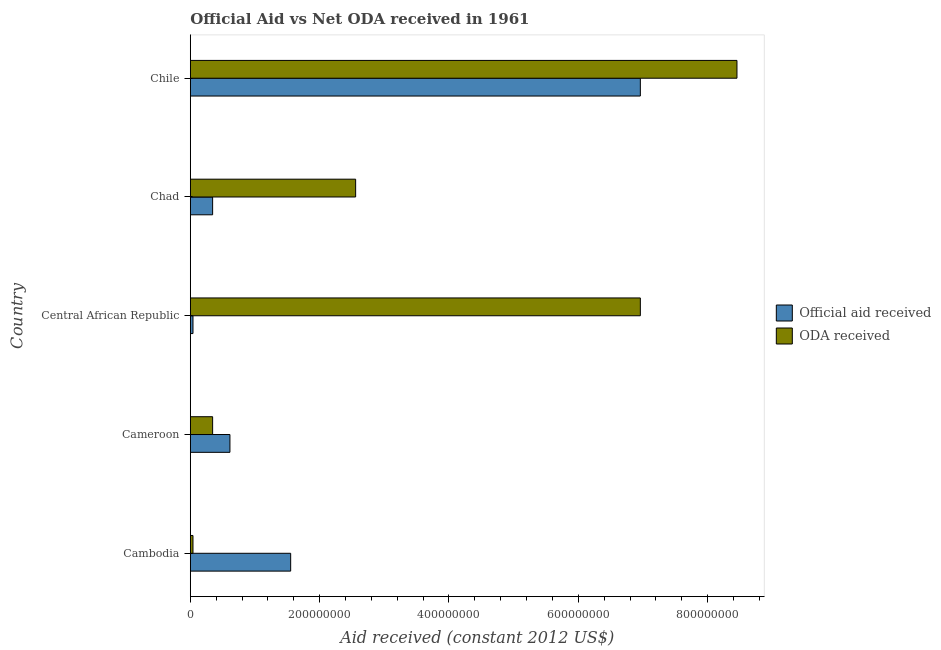How many different coloured bars are there?
Make the answer very short. 2. How many groups of bars are there?
Make the answer very short. 5. Are the number of bars per tick equal to the number of legend labels?
Your answer should be compact. Yes. Are the number of bars on each tick of the Y-axis equal?
Make the answer very short. Yes. What is the label of the 1st group of bars from the top?
Your answer should be very brief. Chile. What is the oda received in Cameroon?
Give a very brief answer. 3.45e+07. Across all countries, what is the maximum oda received?
Offer a very short reply. 8.45e+08. Across all countries, what is the minimum oda received?
Your answer should be very brief. 4.17e+06. In which country was the oda received maximum?
Your response must be concise. Chile. In which country was the oda received minimum?
Your response must be concise. Cambodia. What is the total oda received in the graph?
Provide a short and direct response. 1.84e+09. What is the difference between the official aid received in Cambodia and that in Chile?
Your answer should be very brief. -5.41e+08. What is the difference between the oda received in Central African Republic and the official aid received in Chile?
Keep it short and to the point. 0. What is the average official aid received per country?
Provide a short and direct response. 1.90e+08. What is the difference between the official aid received and oda received in Chad?
Keep it short and to the point. -2.21e+08. In how many countries, is the official aid received greater than 80000000 US$?
Ensure brevity in your answer.  2. What is the ratio of the official aid received in Central African Republic to that in Chile?
Keep it short and to the point. 0.01. What is the difference between the highest and the second highest official aid received?
Ensure brevity in your answer.  5.41e+08. What is the difference between the highest and the lowest oda received?
Offer a terse response. 8.41e+08. In how many countries, is the oda received greater than the average oda received taken over all countries?
Make the answer very short. 2. What does the 2nd bar from the top in Cameroon represents?
Your answer should be compact. Official aid received. What does the 2nd bar from the bottom in Cameroon represents?
Provide a succinct answer. ODA received. How many bars are there?
Offer a terse response. 10. Are all the bars in the graph horizontal?
Offer a terse response. Yes. What is the difference between two consecutive major ticks on the X-axis?
Offer a very short reply. 2.00e+08. Does the graph contain grids?
Keep it short and to the point. No. Where does the legend appear in the graph?
Keep it short and to the point. Center right. How are the legend labels stacked?
Provide a short and direct response. Vertical. What is the title of the graph?
Make the answer very short. Official Aid vs Net ODA received in 1961 . Does "Registered firms" appear as one of the legend labels in the graph?
Provide a short and direct response. No. What is the label or title of the X-axis?
Keep it short and to the point. Aid received (constant 2012 US$). What is the Aid received (constant 2012 US$) of Official aid received in Cambodia?
Keep it short and to the point. 1.55e+08. What is the Aid received (constant 2012 US$) of ODA received in Cambodia?
Offer a very short reply. 4.17e+06. What is the Aid received (constant 2012 US$) in Official aid received in Cameroon?
Your answer should be compact. 6.13e+07. What is the Aid received (constant 2012 US$) in ODA received in Cameroon?
Keep it short and to the point. 3.45e+07. What is the Aid received (constant 2012 US$) of Official aid received in Central African Republic?
Offer a very short reply. 4.17e+06. What is the Aid received (constant 2012 US$) of ODA received in Central African Republic?
Your answer should be very brief. 6.96e+08. What is the Aid received (constant 2012 US$) of Official aid received in Chad?
Your response must be concise. 3.45e+07. What is the Aid received (constant 2012 US$) in ODA received in Chad?
Make the answer very short. 2.56e+08. What is the Aid received (constant 2012 US$) of Official aid received in Chile?
Make the answer very short. 6.96e+08. What is the Aid received (constant 2012 US$) in ODA received in Chile?
Offer a terse response. 8.45e+08. Across all countries, what is the maximum Aid received (constant 2012 US$) in Official aid received?
Your answer should be very brief. 6.96e+08. Across all countries, what is the maximum Aid received (constant 2012 US$) of ODA received?
Give a very brief answer. 8.45e+08. Across all countries, what is the minimum Aid received (constant 2012 US$) of Official aid received?
Provide a succinct answer. 4.17e+06. Across all countries, what is the minimum Aid received (constant 2012 US$) of ODA received?
Your answer should be compact. 4.17e+06. What is the total Aid received (constant 2012 US$) of Official aid received in the graph?
Your answer should be compact. 9.51e+08. What is the total Aid received (constant 2012 US$) of ODA received in the graph?
Offer a very short reply. 1.84e+09. What is the difference between the Aid received (constant 2012 US$) of Official aid received in Cambodia and that in Cameroon?
Offer a very short reply. 9.39e+07. What is the difference between the Aid received (constant 2012 US$) in ODA received in Cambodia and that in Cameroon?
Provide a short and direct response. -3.04e+07. What is the difference between the Aid received (constant 2012 US$) of Official aid received in Cambodia and that in Central African Republic?
Your response must be concise. 1.51e+08. What is the difference between the Aid received (constant 2012 US$) in ODA received in Cambodia and that in Central African Republic?
Provide a succinct answer. -6.92e+08. What is the difference between the Aid received (constant 2012 US$) of Official aid received in Cambodia and that in Chad?
Your answer should be very brief. 1.21e+08. What is the difference between the Aid received (constant 2012 US$) in ODA received in Cambodia and that in Chad?
Offer a terse response. -2.52e+08. What is the difference between the Aid received (constant 2012 US$) of Official aid received in Cambodia and that in Chile?
Make the answer very short. -5.41e+08. What is the difference between the Aid received (constant 2012 US$) of ODA received in Cambodia and that in Chile?
Your response must be concise. -8.41e+08. What is the difference between the Aid received (constant 2012 US$) of Official aid received in Cameroon and that in Central African Republic?
Your response must be concise. 5.71e+07. What is the difference between the Aid received (constant 2012 US$) of ODA received in Cameroon and that in Central African Republic?
Your answer should be compact. -6.61e+08. What is the difference between the Aid received (constant 2012 US$) in Official aid received in Cameroon and that in Chad?
Offer a terse response. 2.68e+07. What is the difference between the Aid received (constant 2012 US$) in ODA received in Cameroon and that in Chad?
Keep it short and to the point. -2.21e+08. What is the difference between the Aid received (constant 2012 US$) of Official aid received in Cameroon and that in Chile?
Provide a succinct answer. -6.35e+08. What is the difference between the Aid received (constant 2012 US$) in ODA received in Cameroon and that in Chile?
Provide a succinct answer. -8.11e+08. What is the difference between the Aid received (constant 2012 US$) in Official aid received in Central African Republic and that in Chad?
Your answer should be very brief. -3.04e+07. What is the difference between the Aid received (constant 2012 US$) of ODA received in Central African Republic and that in Chad?
Give a very brief answer. 4.40e+08. What is the difference between the Aid received (constant 2012 US$) of Official aid received in Central African Republic and that in Chile?
Your response must be concise. -6.92e+08. What is the difference between the Aid received (constant 2012 US$) of ODA received in Central African Republic and that in Chile?
Provide a succinct answer. -1.49e+08. What is the difference between the Aid received (constant 2012 US$) in Official aid received in Chad and that in Chile?
Give a very brief answer. -6.61e+08. What is the difference between the Aid received (constant 2012 US$) in ODA received in Chad and that in Chile?
Give a very brief answer. -5.90e+08. What is the difference between the Aid received (constant 2012 US$) of Official aid received in Cambodia and the Aid received (constant 2012 US$) of ODA received in Cameroon?
Your answer should be very brief. 1.21e+08. What is the difference between the Aid received (constant 2012 US$) in Official aid received in Cambodia and the Aid received (constant 2012 US$) in ODA received in Central African Republic?
Your answer should be very brief. -5.41e+08. What is the difference between the Aid received (constant 2012 US$) of Official aid received in Cambodia and the Aid received (constant 2012 US$) of ODA received in Chad?
Offer a very short reply. -1.00e+08. What is the difference between the Aid received (constant 2012 US$) in Official aid received in Cambodia and the Aid received (constant 2012 US$) in ODA received in Chile?
Make the answer very short. -6.90e+08. What is the difference between the Aid received (constant 2012 US$) of Official aid received in Cameroon and the Aid received (constant 2012 US$) of ODA received in Central African Republic?
Your answer should be compact. -6.35e+08. What is the difference between the Aid received (constant 2012 US$) of Official aid received in Cameroon and the Aid received (constant 2012 US$) of ODA received in Chad?
Keep it short and to the point. -1.94e+08. What is the difference between the Aid received (constant 2012 US$) of Official aid received in Cameroon and the Aid received (constant 2012 US$) of ODA received in Chile?
Offer a very short reply. -7.84e+08. What is the difference between the Aid received (constant 2012 US$) in Official aid received in Central African Republic and the Aid received (constant 2012 US$) in ODA received in Chad?
Ensure brevity in your answer.  -2.52e+08. What is the difference between the Aid received (constant 2012 US$) in Official aid received in Central African Republic and the Aid received (constant 2012 US$) in ODA received in Chile?
Provide a succinct answer. -8.41e+08. What is the difference between the Aid received (constant 2012 US$) of Official aid received in Chad and the Aid received (constant 2012 US$) of ODA received in Chile?
Your answer should be compact. -8.11e+08. What is the average Aid received (constant 2012 US$) of Official aid received per country?
Make the answer very short. 1.90e+08. What is the average Aid received (constant 2012 US$) of ODA received per country?
Your answer should be very brief. 3.67e+08. What is the difference between the Aid received (constant 2012 US$) in Official aid received and Aid received (constant 2012 US$) in ODA received in Cambodia?
Your response must be concise. 1.51e+08. What is the difference between the Aid received (constant 2012 US$) in Official aid received and Aid received (constant 2012 US$) in ODA received in Cameroon?
Make the answer very short. 2.68e+07. What is the difference between the Aid received (constant 2012 US$) of Official aid received and Aid received (constant 2012 US$) of ODA received in Central African Republic?
Your answer should be compact. -6.92e+08. What is the difference between the Aid received (constant 2012 US$) in Official aid received and Aid received (constant 2012 US$) in ODA received in Chad?
Your response must be concise. -2.21e+08. What is the difference between the Aid received (constant 2012 US$) in Official aid received and Aid received (constant 2012 US$) in ODA received in Chile?
Ensure brevity in your answer.  -1.49e+08. What is the ratio of the Aid received (constant 2012 US$) of Official aid received in Cambodia to that in Cameroon?
Offer a very short reply. 2.53. What is the ratio of the Aid received (constant 2012 US$) of ODA received in Cambodia to that in Cameroon?
Your response must be concise. 0.12. What is the ratio of the Aid received (constant 2012 US$) in Official aid received in Cambodia to that in Central African Republic?
Provide a succinct answer. 37.22. What is the ratio of the Aid received (constant 2012 US$) of ODA received in Cambodia to that in Central African Republic?
Keep it short and to the point. 0.01. What is the ratio of the Aid received (constant 2012 US$) in Official aid received in Cambodia to that in Chad?
Your answer should be compact. 4.5. What is the ratio of the Aid received (constant 2012 US$) in ODA received in Cambodia to that in Chad?
Your answer should be very brief. 0.02. What is the ratio of the Aid received (constant 2012 US$) of Official aid received in Cambodia to that in Chile?
Offer a very short reply. 0.22. What is the ratio of the Aid received (constant 2012 US$) of ODA received in Cambodia to that in Chile?
Your answer should be very brief. 0. What is the ratio of the Aid received (constant 2012 US$) in Official aid received in Cameroon to that in Central African Republic?
Keep it short and to the point. 14.7. What is the ratio of the Aid received (constant 2012 US$) of ODA received in Cameroon to that in Central African Republic?
Provide a succinct answer. 0.05. What is the ratio of the Aid received (constant 2012 US$) in Official aid received in Cameroon to that in Chad?
Provide a short and direct response. 1.78. What is the ratio of the Aid received (constant 2012 US$) of ODA received in Cameroon to that in Chad?
Ensure brevity in your answer.  0.14. What is the ratio of the Aid received (constant 2012 US$) of Official aid received in Cameroon to that in Chile?
Offer a terse response. 0.09. What is the ratio of the Aid received (constant 2012 US$) in ODA received in Cameroon to that in Chile?
Keep it short and to the point. 0.04. What is the ratio of the Aid received (constant 2012 US$) of Official aid received in Central African Republic to that in Chad?
Your answer should be compact. 0.12. What is the ratio of the Aid received (constant 2012 US$) of ODA received in Central African Republic to that in Chad?
Offer a very short reply. 2.72. What is the ratio of the Aid received (constant 2012 US$) of Official aid received in Central African Republic to that in Chile?
Provide a succinct answer. 0.01. What is the ratio of the Aid received (constant 2012 US$) of ODA received in Central African Republic to that in Chile?
Make the answer very short. 0.82. What is the ratio of the Aid received (constant 2012 US$) in Official aid received in Chad to that in Chile?
Your answer should be compact. 0.05. What is the ratio of the Aid received (constant 2012 US$) of ODA received in Chad to that in Chile?
Make the answer very short. 0.3. What is the difference between the highest and the second highest Aid received (constant 2012 US$) of Official aid received?
Make the answer very short. 5.41e+08. What is the difference between the highest and the second highest Aid received (constant 2012 US$) of ODA received?
Give a very brief answer. 1.49e+08. What is the difference between the highest and the lowest Aid received (constant 2012 US$) of Official aid received?
Provide a succinct answer. 6.92e+08. What is the difference between the highest and the lowest Aid received (constant 2012 US$) in ODA received?
Your answer should be very brief. 8.41e+08. 